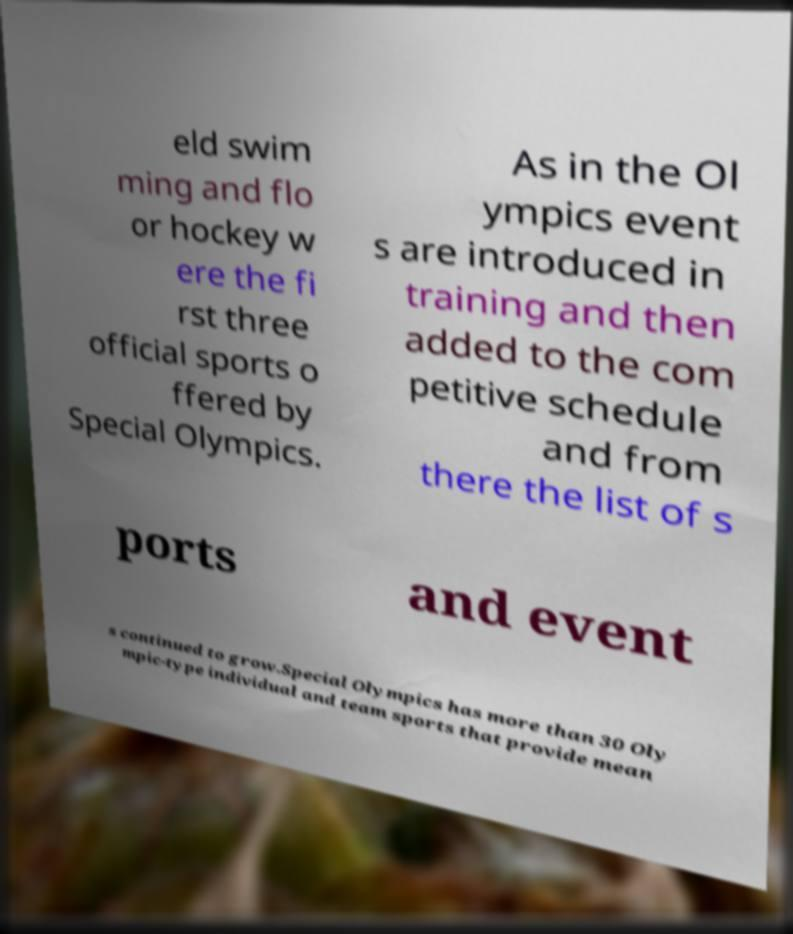Can you read and provide the text displayed in the image?This photo seems to have some interesting text. Can you extract and type it out for me? eld swim ming and flo or hockey w ere the fi rst three official sports o ffered by Special Olympics. As in the Ol ympics event s are introduced in training and then added to the com petitive schedule and from there the list of s ports and event s continued to grow.Special Olympics has more than 30 Oly mpic-type individual and team sports that provide mean 